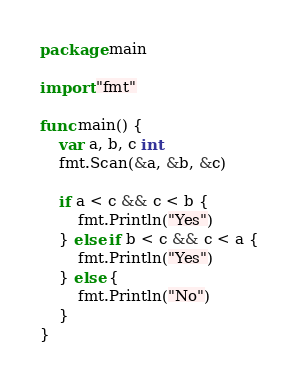<code> <loc_0><loc_0><loc_500><loc_500><_Go_>package main

import "fmt"

func main() {
	var a, b, c int
	fmt.Scan(&a, &b, &c)

	if a < c && c < b {
		fmt.Println("Yes")
	} else if b < c && c < a {
		fmt.Println("Yes")
	} else {
		fmt.Println("No")
	}
}
</code> 